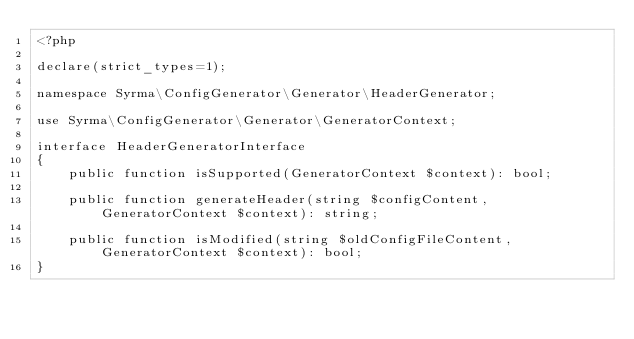<code> <loc_0><loc_0><loc_500><loc_500><_PHP_><?php

declare(strict_types=1);

namespace Syrma\ConfigGenerator\Generator\HeaderGenerator;

use Syrma\ConfigGenerator\Generator\GeneratorContext;

interface HeaderGeneratorInterface
{
    public function isSupported(GeneratorContext $context): bool;

    public function generateHeader(string $configContent, GeneratorContext $context): string;

    public function isModified(string $oldConfigFileContent, GeneratorContext $context): bool;
}
</code> 